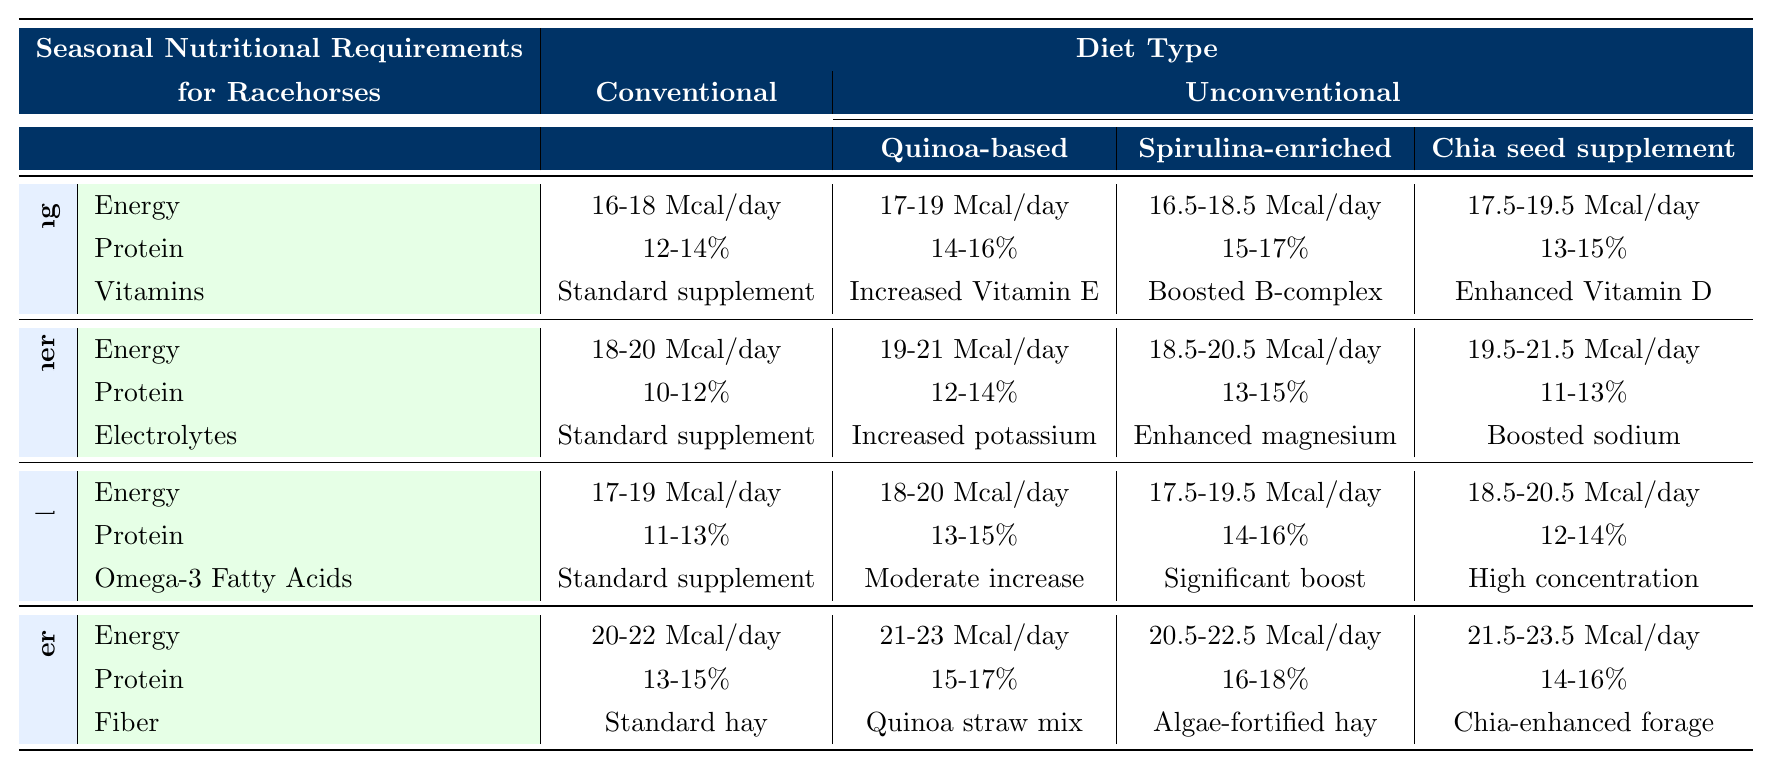What are the nutritional requirements for protein in the Summer for a Chia seed supplement diet? In the Summer season, the nutritional requirement for protein on a Chia seed supplement diet is listed as 11-13%.
Answer: 11-13% What is the energy requirement for a Spirulina-enriched diet during Fall? The table indicates that the energy requirement for a Spirulina-enriched diet in the Fall is 17.5-19.5 Mcal/day.
Answer: 17.5-19.5 Mcal/day Is the energy requirement for Winter higher than that for Spring in a Quinoa-based diet? In Winter, the Quinoa-based diet requires 21-23 Mcal/day, while in Spring it requires 17-19 Mcal/day. Since 21-23 is greater than 17-19, the statement is true.
Answer: Yes What is the average protein requirement for conventional diets across all seasons? For Spring, it's 13%; Summer it's 11%; Fall it's 12%; Winter it's 14%. The average is calculated as (12 + 11 + 12 + 14) / 4 = 12.25%.
Answer: 12.25% Which unconventional diet has the highest energy requirement in Winter? In Winter, the Quinoa-based diet has an energy requirement of 21-23 Mcal/day, Spirulina-enriched has 20.5-22.5 Mcal/day, and Chia seed has 21.5-23.5 Mcal/day. Since 21.5-23.5 is higher, the Chia seed supplement diet has the highest requirement.
Answer: Chia seed supplement Are there any electrolyte requirements in Spring for a conventional diet? The table does not list any electrolyte requirements for Spring under the conventional diet, indicating that the answer is no.
Answer: No What is the difference in protein percentage between Fall and Summer for the Spirulina-enriched diet? In Fall, the Spirulina-enriched diet requires 14-16%, and in Summer, it requires 13-15%. The difference shows that Fall requires a higher percentage. Therefore, the difference is 1-1%.
Answer: 1% Which unconventional diet requires the most vitamins during Spring? In Spring, the Quinoa-based diet includes increased Vitamin E, Spirulina-enriched offers boosted B-complex, and Chia seed supplement presents enhanced Vitamin D. All these enhance vitamins but don’t specify quantity for comparison. Thus, a direct comparison is not possible. However, all diets vary in their specific enhancements.
Answer: Not directly comparable What is the standard supplement for protein in Winter on a conventional diet? The table states that the protein requirement for Winter on a conventional diet is 13-15%. It is categorized under "Standard supplement."
Answer: 13-15% 